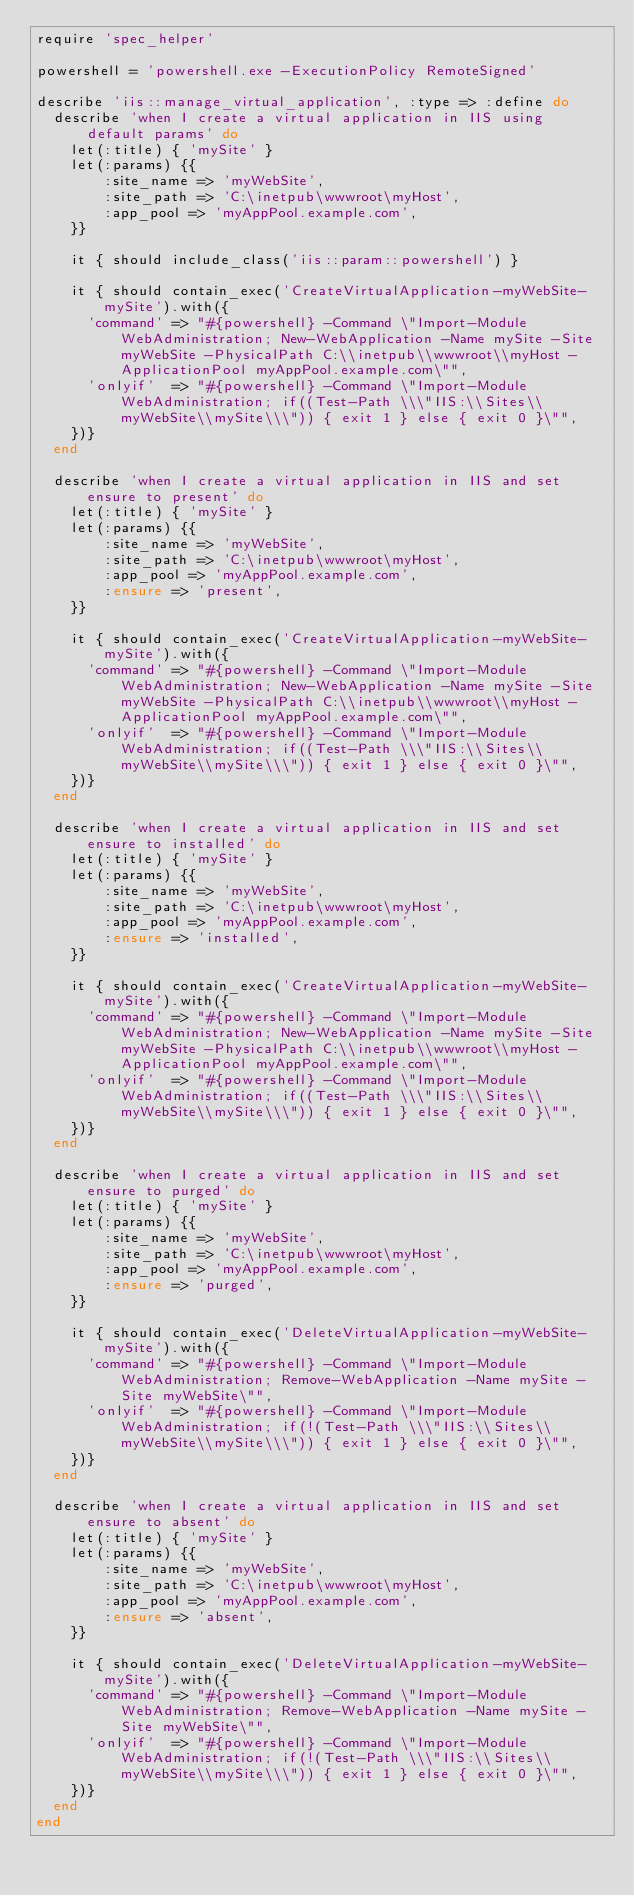Convert code to text. <code><loc_0><loc_0><loc_500><loc_500><_Ruby_>require 'spec_helper'

powershell = 'powershell.exe -ExecutionPolicy RemoteSigned'

describe 'iis::manage_virtual_application', :type => :define do
  describe 'when I create a virtual application in IIS using default params' do
    let(:title) { 'mySite' }
    let(:params) {{
        :site_name => 'myWebSite',
        :site_path => 'C:\inetpub\wwwroot\myHost',
        :app_pool => 'myAppPool.example.com',
    }}

    it { should include_class('iis::param::powershell') }

    it { should contain_exec('CreateVirtualApplication-myWebSite-mySite').with({
      'command' => "#{powershell} -Command \"Import-Module WebAdministration; New-WebApplication -Name mySite -Site myWebSite -PhysicalPath C:\\inetpub\\wwwroot\\myHost -ApplicationPool myAppPool.example.com\"",
      'onlyif'  => "#{powershell} -Command \"Import-Module WebAdministration; if((Test-Path \\\"IIS:\\Sites\\myWebSite\\mySite\\\")) { exit 1 } else { exit 0 }\"",
    })}
  end

  describe 'when I create a virtual application in IIS and set ensure to present' do
    let(:title) { 'mySite' }
    let(:params) {{
        :site_name => 'myWebSite',
        :site_path => 'C:\inetpub\wwwroot\myHost',
        :app_pool => 'myAppPool.example.com',
        :ensure => 'present',
    }}

    it { should contain_exec('CreateVirtualApplication-myWebSite-mySite').with({
      'command' => "#{powershell} -Command \"Import-Module WebAdministration; New-WebApplication -Name mySite -Site myWebSite -PhysicalPath C:\\inetpub\\wwwroot\\myHost -ApplicationPool myAppPool.example.com\"",
      'onlyif'  => "#{powershell} -Command \"Import-Module WebAdministration; if((Test-Path \\\"IIS:\\Sites\\myWebSite\\mySite\\\")) { exit 1 } else { exit 0 }\"",
    })}
  end

  describe 'when I create a virtual application in IIS and set ensure to installed' do
    let(:title) { 'mySite' }
    let(:params) {{
        :site_name => 'myWebSite',
        :site_path => 'C:\inetpub\wwwroot\myHost',
        :app_pool => 'myAppPool.example.com',
        :ensure => 'installed',
    }}

    it { should contain_exec('CreateVirtualApplication-myWebSite-mySite').with({
      'command' => "#{powershell} -Command \"Import-Module WebAdministration; New-WebApplication -Name mySite -Site myWebSite -PhysicalPath C:\\inetpub\\wwwroot\\myHost -ApplicationPool myAppPool.example.com\"",
      'onlyif'  => "#{powershell} -Command \"Import-Module WebAdministration; if((Test-Path \\\"IIS:\\Sites\\myWebSite\\mySite\\\")) { exit 1 } else { exit 0 }\"",
    })}
  end

  describe 'when I create a virtual application in IIS and set ensure to purged' do
    let(:title) { 'mySite' }
    let(:params) {{
        :site_name => 'myWebSite',
        :site_path => 'C:\inetpub\wwwroot\myHost',
        :app_pool => 'myAppPool.example.com',
        :ensure => 'purged',
    }}

    it { should contain_exec('DeleteVirtualApplication-myWebSite-mySite').with({
      'command' => "#{powershell} -Command \"Import-Module WebAdministration; Remove-WebApplication -Name mySite -Site myWebSite\"",
      'onlyif'  => "#{powershell} -Command \"Import-Module WebAdministration; if(!(Test-Path \\\"IIS:\\Sites\\myWebSite\\mySite\\\")) { exit 1 } else { exit 0 }\"",
    })}
  end

  describe 'when I create a virtual application in IIS and set ensure to absent' do
    let(:title) { 'mySite' }
    let(:params) {{
        :site_name => 'myWebSite',
        :site_path => 'C:\inetpub\wwwroot\myHost',
        :app_pool => 'myAppPool.example.com',
        :ensure => 'absent',
    }}

    it { should contain_exec('DeleteVirtualApplication-myWebSite-mySite').with({
      'command' => "#{powershell} -Command \"Import-Module WebAdministration; Remove-WebApplication -Name mySite -Site myWebSite\"",
      'onlyif'  => "#{powershell} -Command \"Import-Module WebAdministration; if(!(Test-Path \\\"IIS:\\Sites\\myWebSite\\mySite\\\")) { exit 1 } else { exit 0 }\"",
    })}
  end
end</code> 